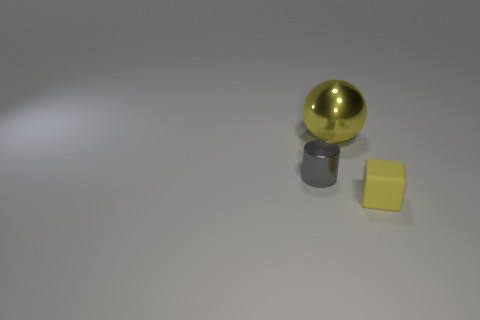Is there anything else that is the same material as the cube?
Give a very brief answer. No. The big thing that is the same material as the tiny gray thing is what color?
Offer a very short reply. Yellow. What number of large gray blocks have the same material as the large yellow object?
Ensure brevity in your answer.  0. There is a yellow object behind the shiny cylinder; is it the same size as the object in front of the tiny metallic cylinder?
Provide a succinct answer. No. What is the material of the yellow thing that is on the left side of the object right of the large shiny object?
Your response must be concise. Metal. Are there fewer gray shiny objects that are in front of the small gray metal cylinder than tiny rubber things that are behind the small yellow matte thing?
Provide a short and direct response. No. What is the material of the ball that is the same color as the rubber object?
Offer a terse response. Metal. Are there any other things that have the same shape as the gray metal object?
Your answer should be very brief. No. There is a tiny object behind the small cube; what is its material?
Make the answer very short. Metal. Are there any other things that have the same size as the yellow metal sphere?
Provide a short and direct response. No. 